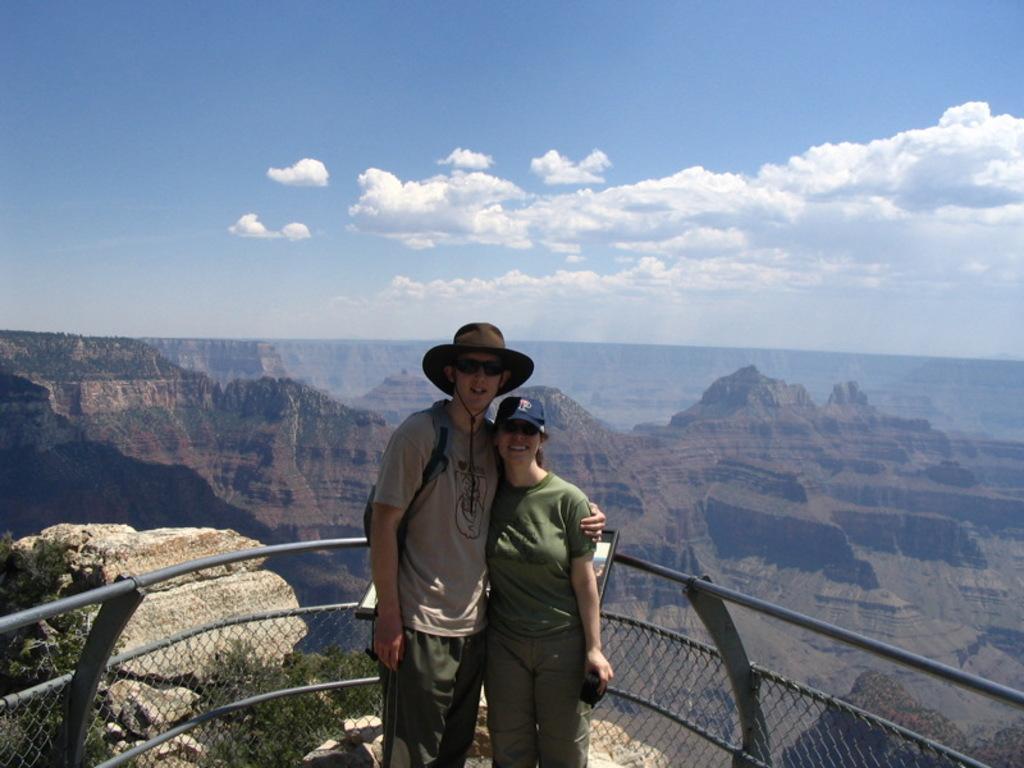Can you describe this image briefly? In this picture we can see one man and woman standing in front of the fence and taking pictures, back side we can see so many hills. 